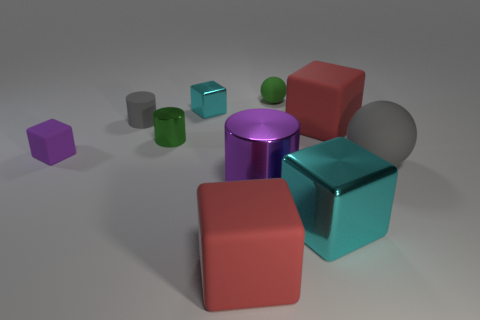What might be the purpose of arranging these geometric shapes in this particular way? This arrangement could serve several purposes. It might be an artistic display intended to showcase the interplay of different geometric forms and colors. Alternatively, it could be part of a visualization in a study on spatial recognition or an educational tool for teaching about shapes, volume, and color theory. 